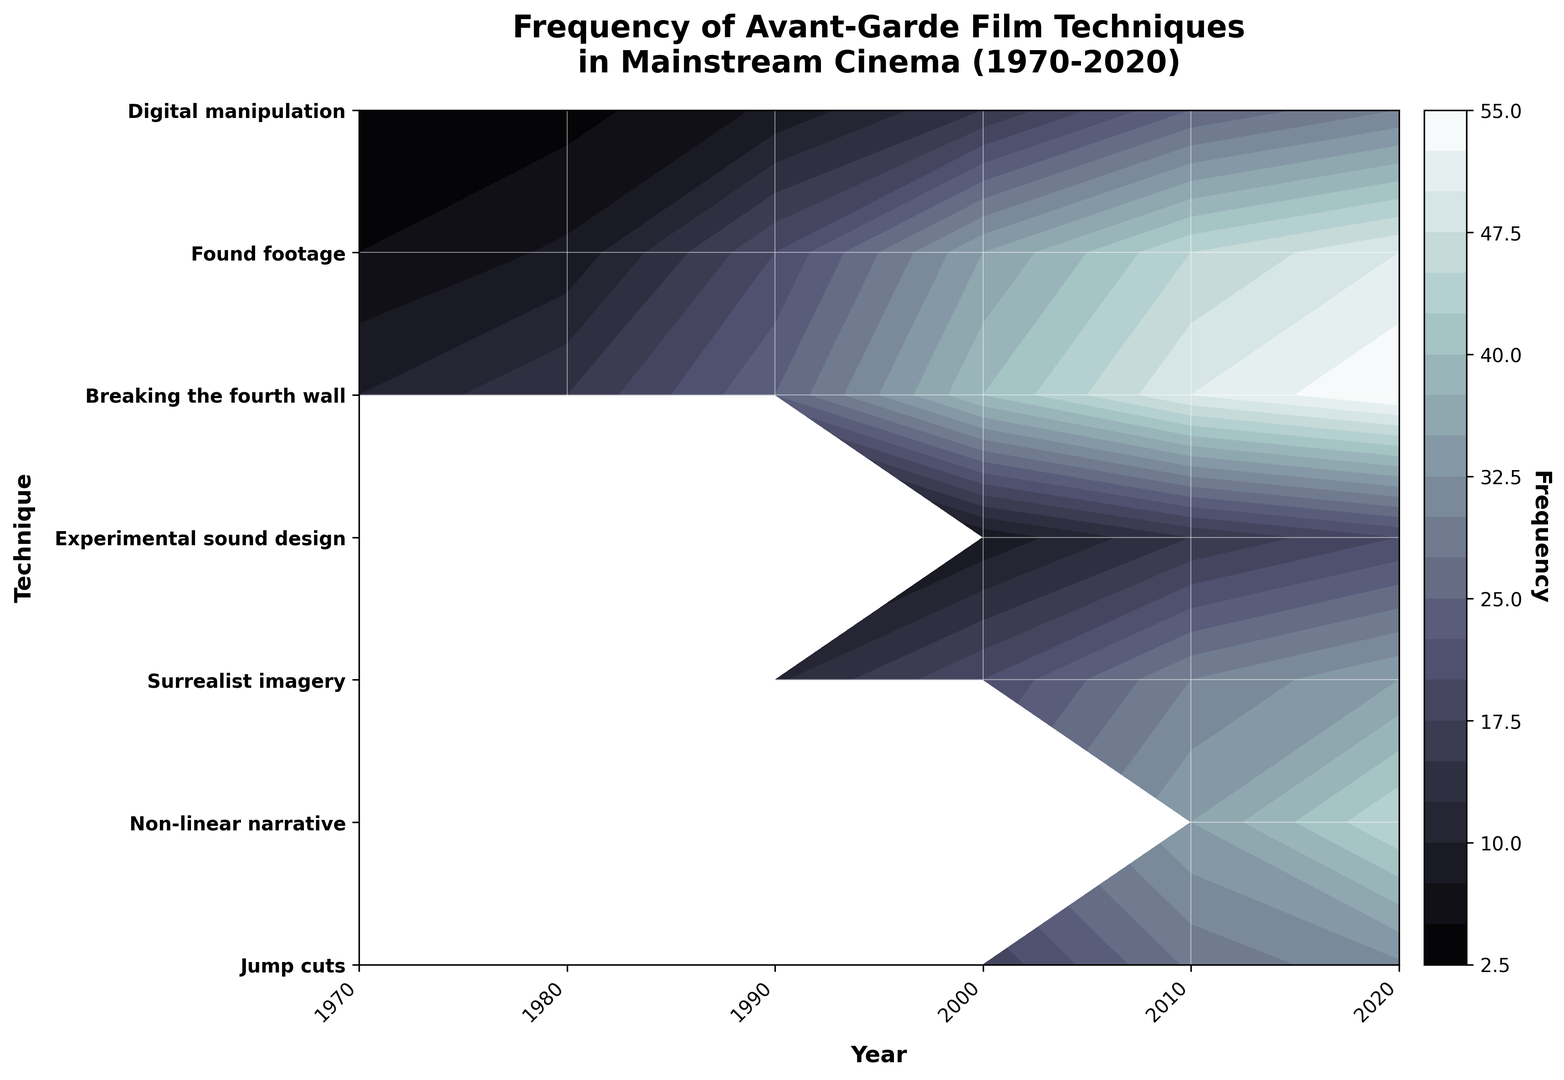What is the highest frequency of any avant-garde technique in 2020? The figure shows the contour plot ranging the years from 1970 to 2020 and different techniques on the y-axis. By locating the year 2020, we find the highest color intensity corresponding to 55 (Jump Cuts).
Answer: 55 Which technique had the most significant increase in frequency from 1970 to 2020? To determine this, compare the frequencies of each technique in 1970 and 2020 by following the contours. Jump Cuts increased from 10 (1970) to 55 (2020). No other technique shows a similar magnitude of increase.
Answer: Jump cuts Which avant-garde technique shows consistent growth in usage from 1970 to 2020? By observing the contour plot, one can see which techniques have a steady rise in contour levels over the years. Both Jump Cuts and Non-linear Narrative show consistent growth, but Jump Cuts have more frequent increases in their contour levels.
Answer: Jump cuts Between 2000 and 2010, which technique saw the highest absolute increase in frequency? The figure plots the frequency for both years. Jump Cuts increased from 40 (2000) to 50 (2010), which is a 10 unit increase. None of the other techniques show as significant a jump in the contour shades during this period.
Answer: Jump cuts Which year introduced the most new avant-garde film techniques? From the contour plot, notice added techniques over the years. 1990 introduced "Breaking the Fourth Wall," whereas 2000 introduced "Found Footage," and 2010 introduced "Digital Manipulation." In 2010, two new techniques were introduced: Found Footage and Digital Manipulation.
Answer: 2010 What is the average frequency of Non-linear Narrative from 1970 to 2020? Sum the frequencies of Non-linear Narrative over the listed years (5 + 8 + 20 + 35 + 45 + 50) and divide by the number of years (6). The calculation: (5 + 8 + 20 + 35 + 45 + 50) / 6 = 163 / 6 ≈ 27.17.
Answer: 27.17 Between Jump Cuts and Experimental Sound Design in 2010, which technique had a higher frequency? Locate the 2010 contour for both techniques. Jump Cuts have a frequency of 50, while Experimental Sound Design stands at 30.
Answer: Jump cuts 